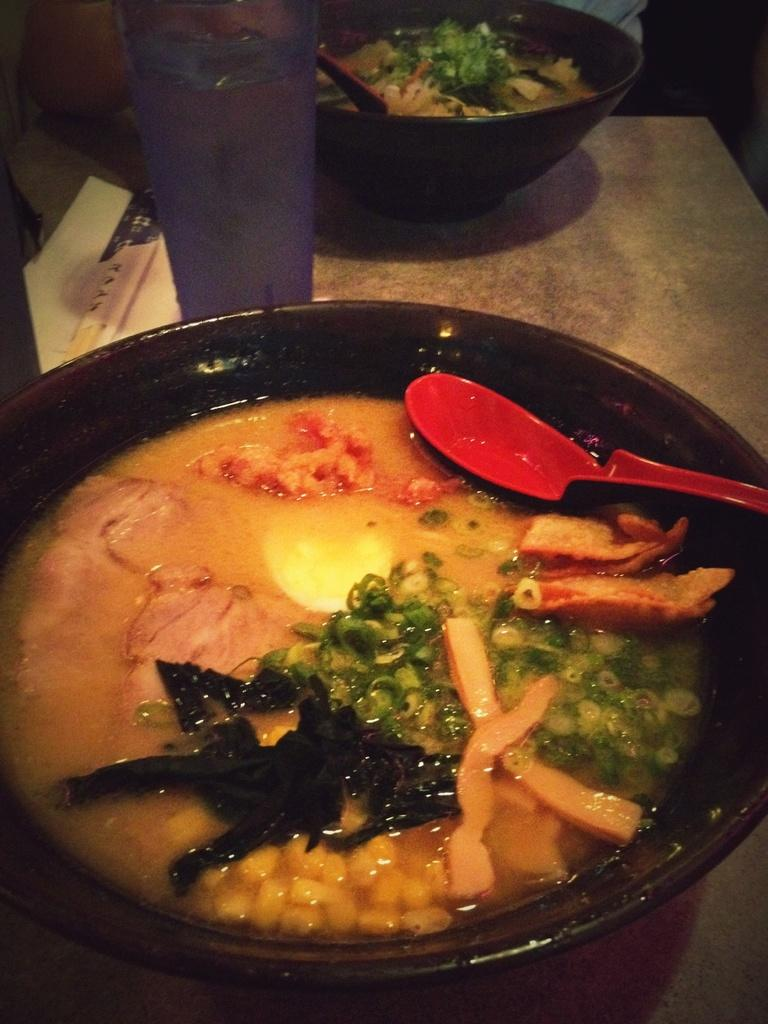Where was the image taken? The image was taken indoors. What furniture is visible in the image? There is a table in the image. How many bowls of food are on the table? There are two bowls of food on the table. What utensils are on the table? There are two spoons on the table. What beverage is present in the image? There is a glass of water on the table. Can you describe the person in the image? There is a person at the top of the image. How many chickens are present in the image? There are no chickens present in the image. What type of property does the person own in the image? There is no information about the person's property in the image. 